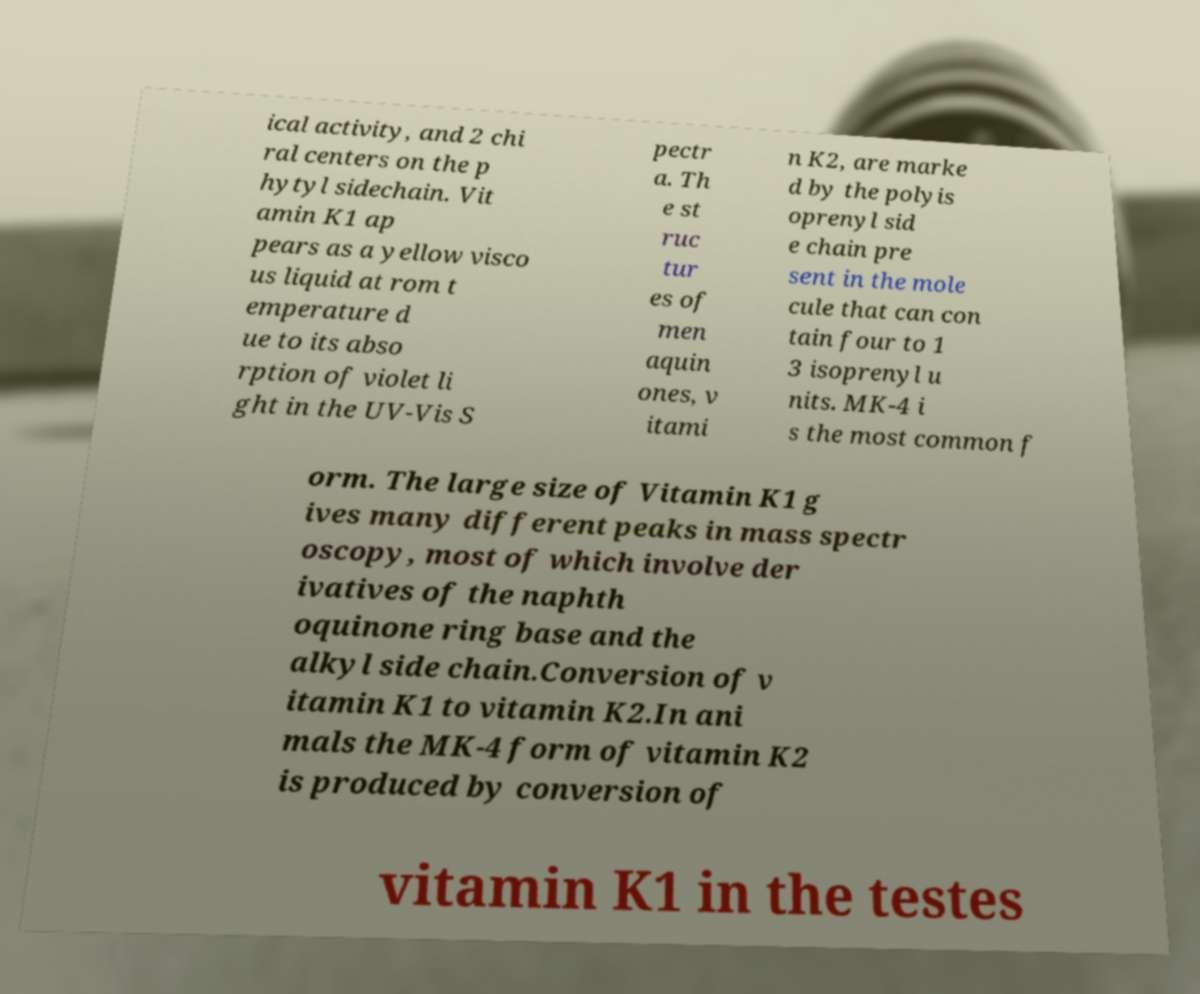What messages or text are displayed in this image? I need them in a readable, typed format. ical activity, and 2 chi ral centers on the p hytyl sidechain. Vit amin K1 ap pears as a yellow visco us liquid at rom t emperature d ue to its abso rption of violet li ght in the UV-Vis S pectr a. Th e st ruc tur es of men aquin ones, v itami n K2, are marke d by the polyis oprenyl sid e chain pre sent in the mole cule that can con tain four to 1 3 isoprenyl u nits. MK-4 i s the most common f orm. The large size of Vitamin K1 g ives many different peaks in mass spectr oscopy, most of which involve der ivatives of the naphth oquinone ring base and the alkyl side chain.Conversion of v itamin K1 to vitamin K2.In ani mals the MK-4 form of vitamin K2 is produced by conversion of vitamin K1 in the testes 